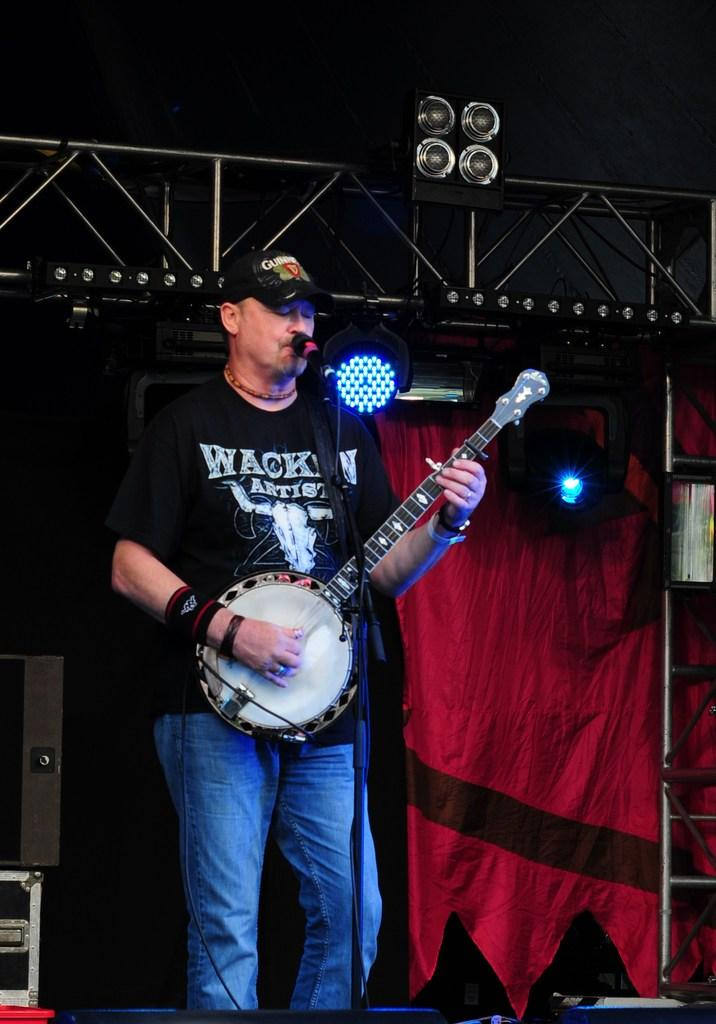What is the person in the image doing? The person is playing a musical instrument in the image. What is the person standing in front of? The person is in front of a mic. What can be seen in the background of the image? There are lights visible in the image. What type of material are the rods made of? The metal rods are present in the image. What type of window treatment is visible in the image? There are curtains in the image. What other equipment can be seen in the image? Other equipment is visible in the image. What type of clock is visible on the wall in the image? There is no clock visible on the wall in the image. What type of shoe is the person wearing while playing the musical instrument? The image does not show the person's footwear, so it cannot be determined what type of shoe they are wearing. 